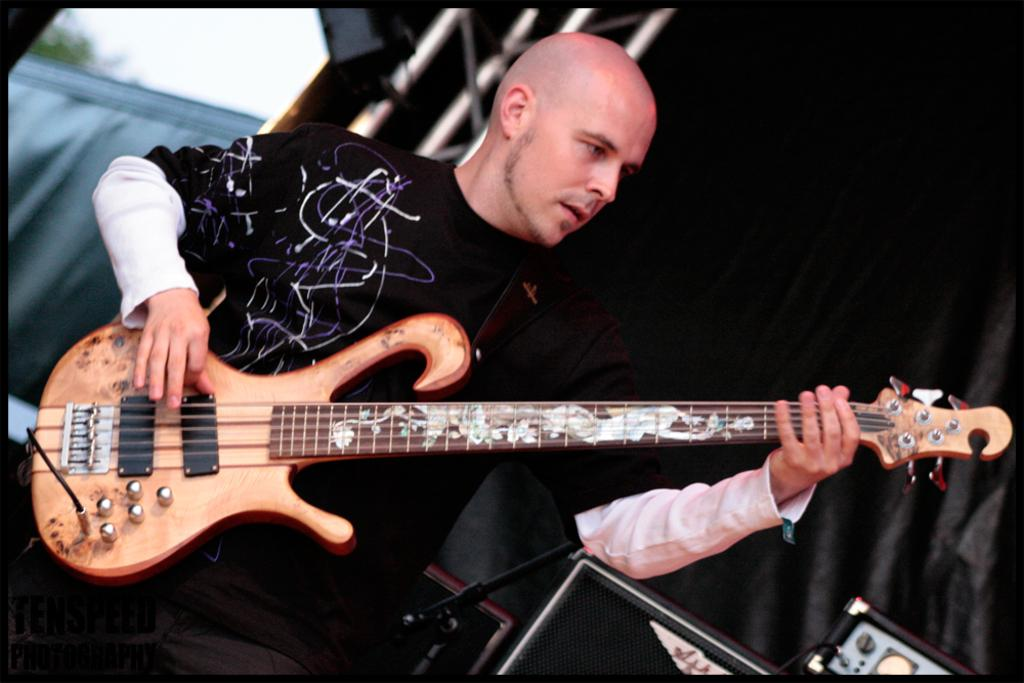What is the main subject of the image? There is a person in the image. What is the person doing in the image? The person is standing and playing a guitar. Can you describe the background of the image? The background is in black color. Are there any other objects visible in the image besides the person and the guitar? Yes, there are other objects in the background. How many dimes can be seen on the guitar in the image? There are no dimes visible on the guitar in the image. Is there an airplane flying in the background of the image? There is no airplane visible in the image; the background is in black color. 